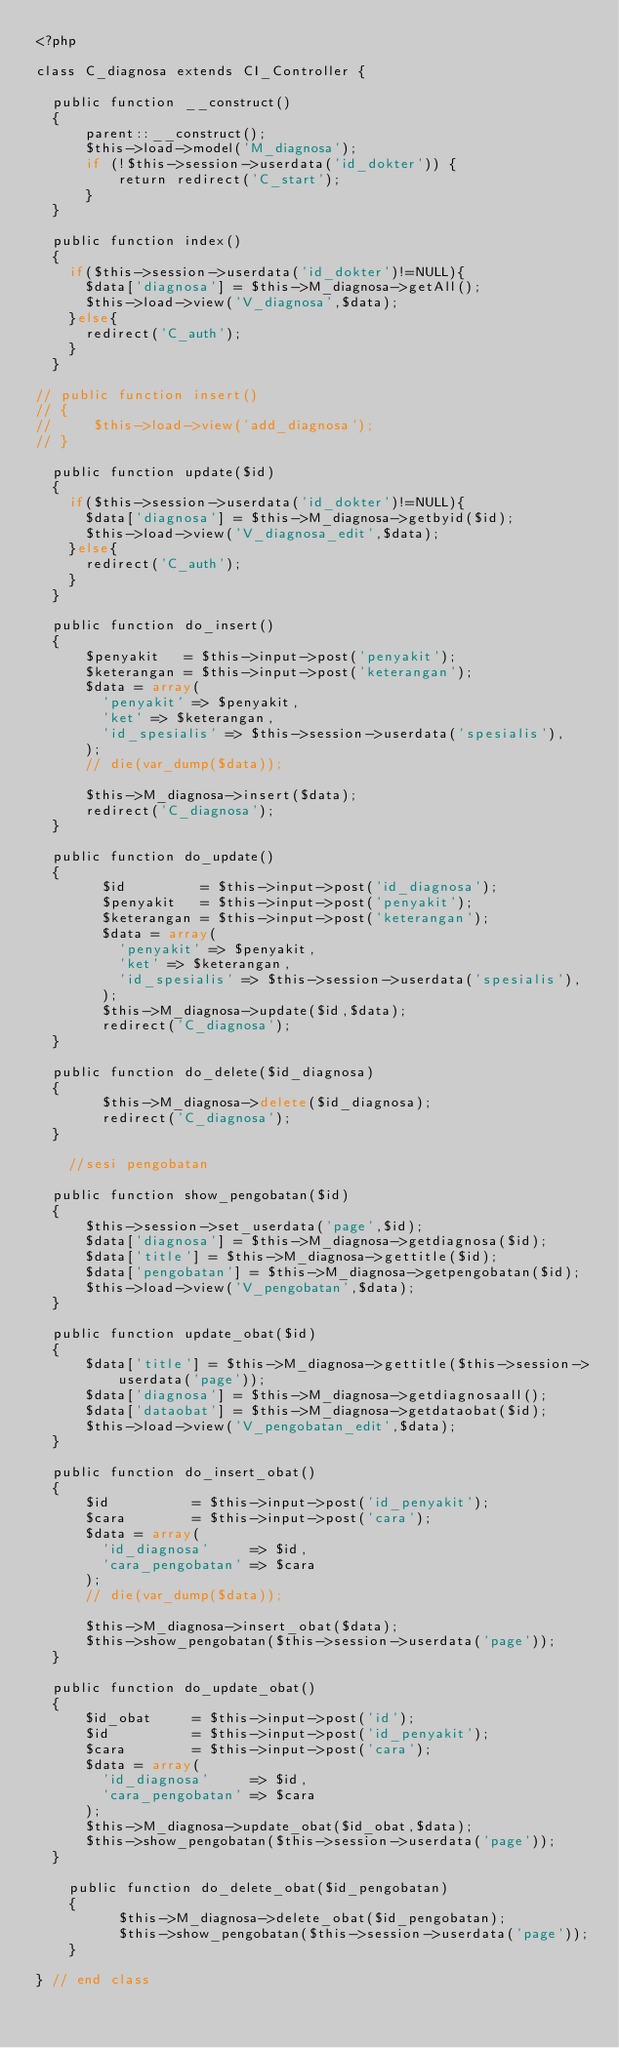<code> <loc_0><loc_0><loc_500><loc_500><_PHP_><?php

class C_diagnosa extends CI_Controller {

  public function __construct()
  {
      parent::__construct();
      $this->load->model('M_diagnosa');
      if (!$this->session->userdata('id_dokter')) {
          return redirect('C_start');
      }
  }

  public function index()
  {
    if($this->session->userdata('id_dokter')!=NULL){
      $data['diagnosa'] = $this->M_diagnosa->getAll();
      $this->load->view('V_diagnosa',$data);
    }else{
      redirect('C_auth');
    }
  }

// public function insert()
// {
//     $this->load->view('add_diagnosa');
// }

  public function update($id)
  {
    if($this->session->userdata('id_dokter')!=NULL){
      $data['diagnosa'] = $this->M_diagnosa->getbyid($id);
      $this->load->view('V_diagnosa_edit',$data);
    }else{
      redirect('C_auth');
    }
  }

  public function do_insert()
  {
      $penyakit   = $this->input->post('penyakit');
      $keterangan = $this->input->post('keterangan');
      $data = array(
        'penyakit' => $penyakit,
        'ket' => $keterangan,
        'id_spesialis' => $this->session->userdata('spesialis'),
      );
      // die(var_dump($data));

      $this->M_diagnosa->insert($data);
      redirect('C_diagnosa');
  }

  public function do_update()
  {
        $id         = $this->input->post('id_diagnosa');
        $penyakit   = $this->input->post('penyakit');
        $keterangan = $this->input->post('keterangan');
        $data = array(
          'penyakit' => $penyakit,
          'ket' => $keterangan,
          'id_spesialis' => $this->session->userdata('spesialis'),
        );
        $this->M_diagnosa->update($id,$data);
        redirect('C_diagnosa');
  }

  public function do_delete($id_diagnosa)
  {
        $this->M_diagnosa->delete($id_diagnosa);
        redirect('C_diagnosa');
  }

    //sesi pengobatan

  public function show_pengobatan($id)
  {
      $this->session->set_userdata('page',$id);
      $data['diagnosa'] = $this->M_diagnosa->getdiagnosa($id);
      $data['title'] = $this->M_diagnosa->gettitle($id);
      $data['pengobatan'] = $this->M_diagnosa->getpengobatan($id);
      $this->load->view('V_pengobatan',$data);
  }

  public function update_obat($id)
  {
      $data['title'] = $this->M_diagnosa->gettitle($this->session->userdata('page'));
      $data['diagnosa'] = $this->M_diagnosa->getdiagnosaall();
      $data['dataobat'] = $this->M_diagnosa->getdataobat($id);
      $this->load->view('V_pengobatan_edit',$data);
  }

  public function do_insert_obat()
  {
      $id          = $this->input->post('id_penyakit');
      $cara        = $this->input->post('cara');
      $data = array(
        'id_diagnosa'     => $id,
        'cara_pengobatan' => $cara
      );
      // die(var_dump($data));

      $this->M_diagnosa->insert_obat($data);
      $this->show_pengobatan($this->session->userdata('page'));
  }

  public function do_update_obat()
  {
      $id_obat     = $this->input->post('id');
      $id          = $this->input->post('id_penyakit');
      $cara        = $this->input->post('cara');
      $data = array(
        'id_diagnosa'     => $id,
        'cara_pengobatan' => $cara
      );
      $this->M_diagnosa->update_obat($id_obat,$data);
      $this->show_pengobatan($this->session->userdata('page'));
  }

    public function do_delete_obat($id_pengobatan)
    {
          $this->M_diagnosa->delete_obat($id_pengobatan);
          $this->show_pengobatan($this->session->userdata('page'));
    }

} // end class
</code> 